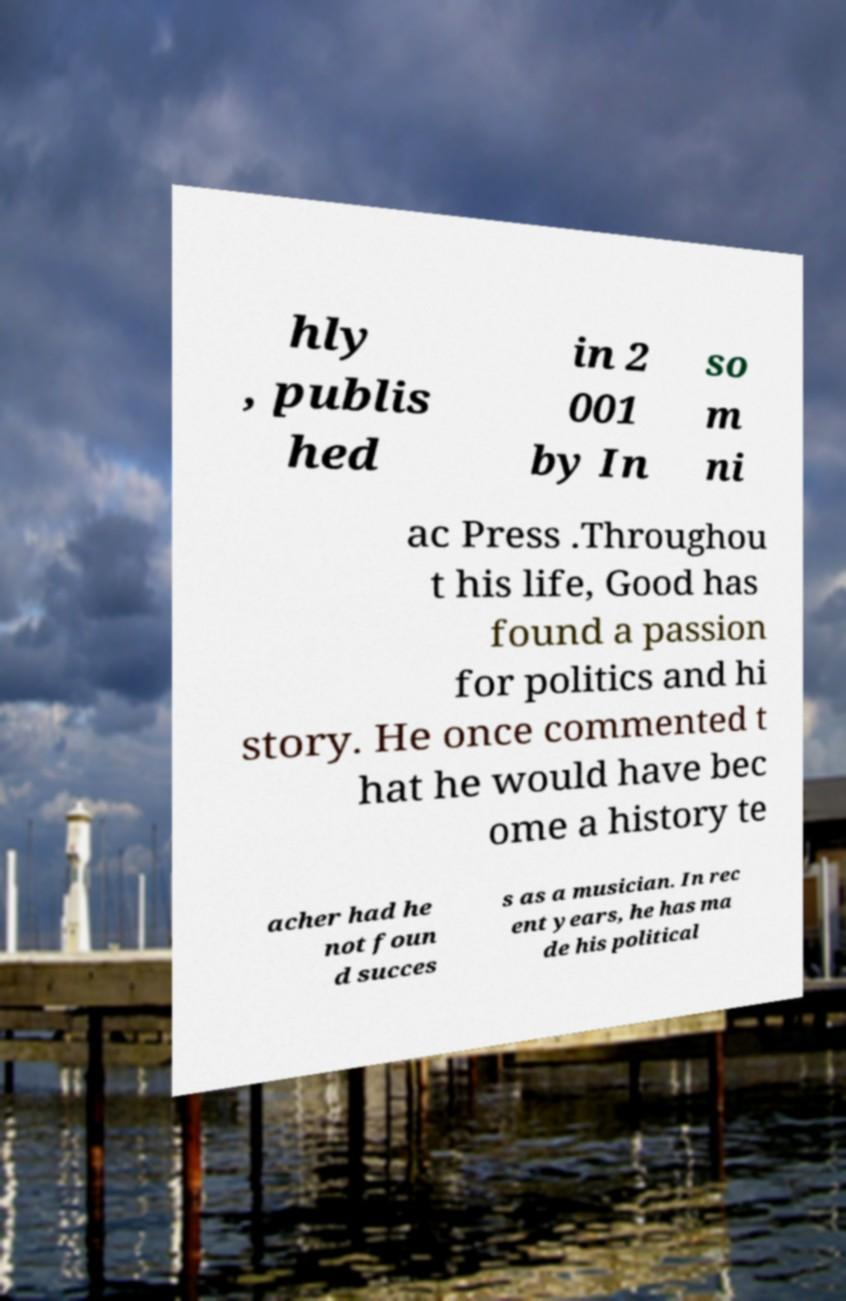For documentation purposes, I need the text within this image transcribed. Could you provide that? hly , publis hed in 2 001 by In so m ni ac Press .Throughou t his life, Good has found a passion for politics and hi story. He once commented t hat he would have bec ome a history te acher had he not foun d succes s as a musician. In rec ent years, he has ma de his political 